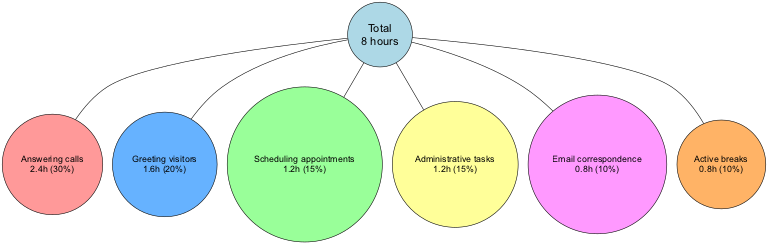What is the total number of hours in a typical workday for a receptionist? The diagram specifies the total number of hours in the center node, which states "Total\n8 hours". Hence, the total hours is directly mentioned there.
Answer: 8 hours Which task takes the longest time during the workday? By examining the time allocated for each task, "Answering calls" has the highest value at 2.4 hours, which is indicated in its corresponding node.
Answer: Answering calls What percentage of the workday is allocated to Email correspondence? The segment for Email correspondence shows "10%" in its label as part of its description. This is a direct representation in the chart.
Answer: 10% How many tasks are represented in the diagram? The diagram includes six segments/tasks as displayed by the six nodes branching from the center node. Counting these tasks yields the total.
Answer: 6 What is the total percentage allocated to Active breaks and Email correspondence combined? The diagram lists "Active breaks" as 10% and "Email correspondence" also as 10%. Adding these two percentages together gives a combined total of 20%.
Answer: 20% Which task is allocated the same amount of time as Administrative tasks? According to the diagram, both "Scheduling appointments" and "Administrative tasks" are allocated 1.2 hours, which can be deduced from the respective node labels.
Answer: Scheduling appointments What color represents the task of Greeting visitors? The diagram uses a specific color for each task, and "Greeting visitors" is colored with the code that corresponds to the second node. By checking the color distribution of the segments, we find that it matches the color of the second segment, which is light blue.
Answer: Light blue What is the total percentage representation of all tasks combined? The diagram indicates the percentage allocation for each task by showing each segment's data; when all the percentages (30% + 20% + 15% + 15% + 10% + 10%) are summed, they total up to 100%.
Answer: 100% 